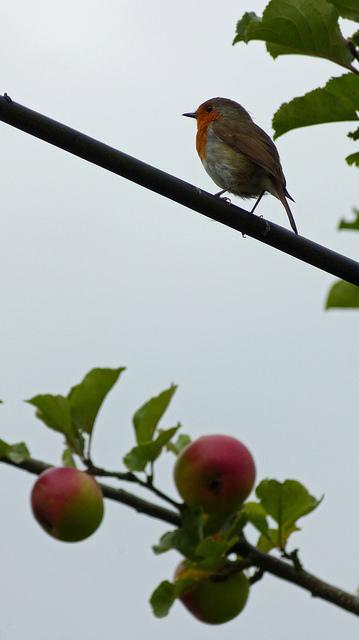What color is the fruit?
Quick response, please. Red. What fruit is in the picture?
Concise answer only. Apple. What is the bird standing on?
Give a very brief answer. Branch. Could it be early spring?
Write a very short answer. Yes. 